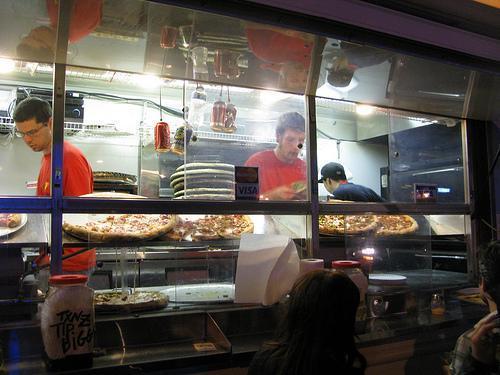How many workers?
Give a very brief answer. 3. How many workers have red t-shirts?
Give a very brief answer. 2. How many people are wearing hats?
Give a very brief answer. 1. 